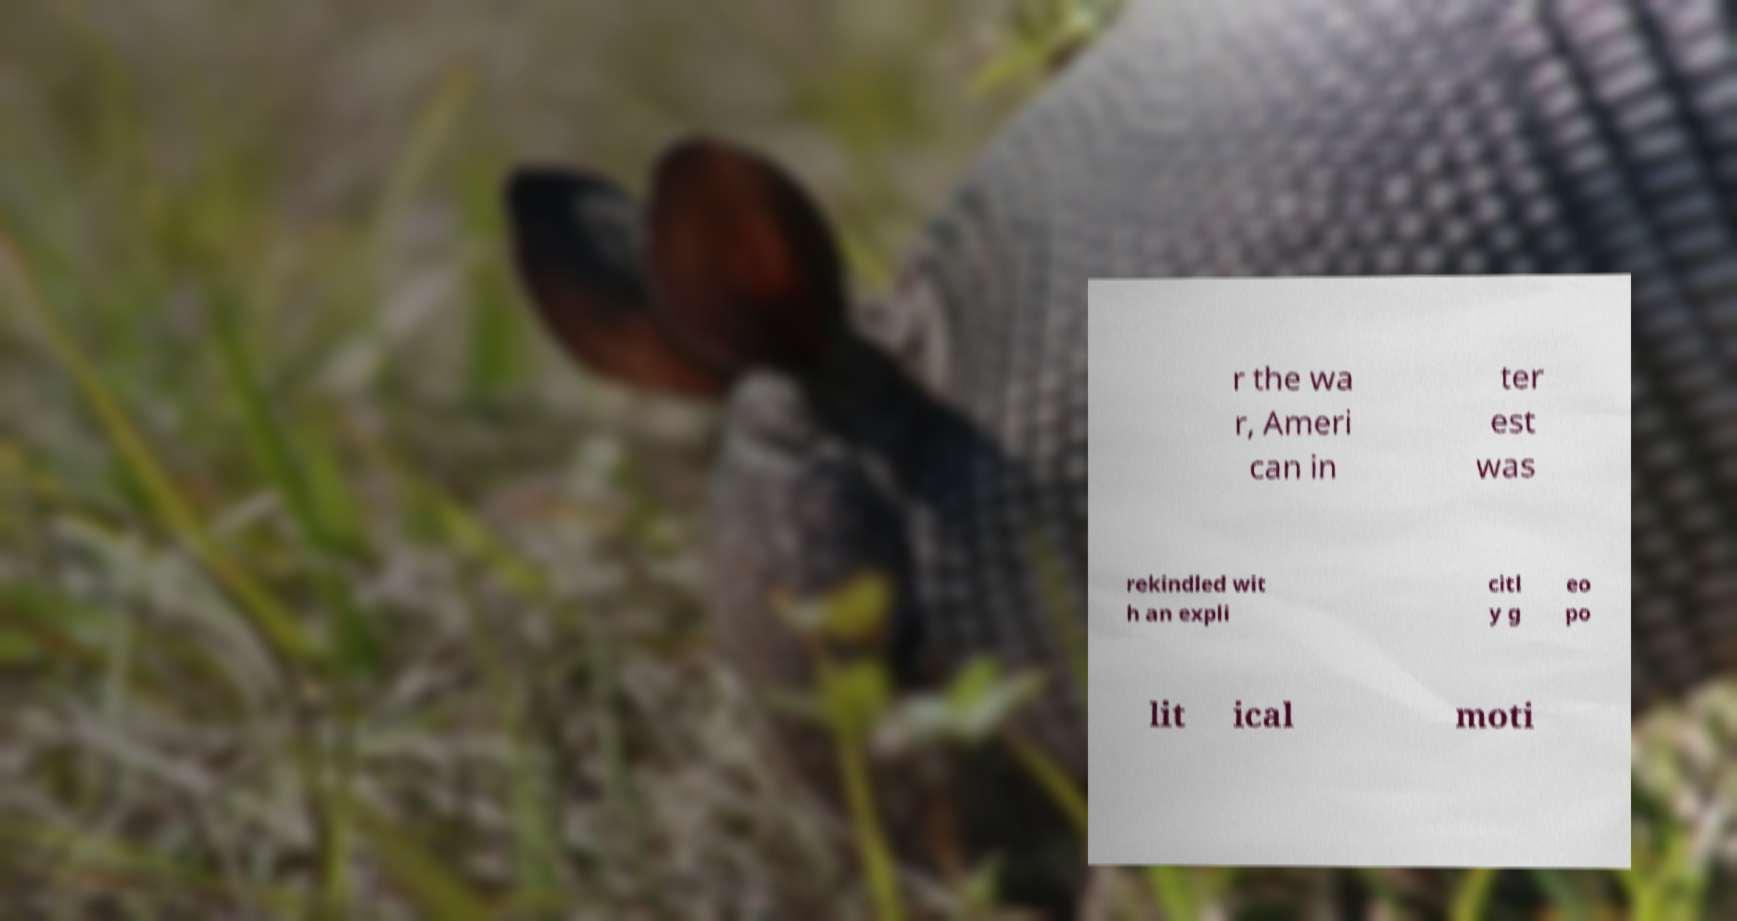I need the written content from this picture converted into text. Can you do that? r the wa r, Ameri can in ter est was rekindled wit h an expli citl y g eo po lit ical moti 